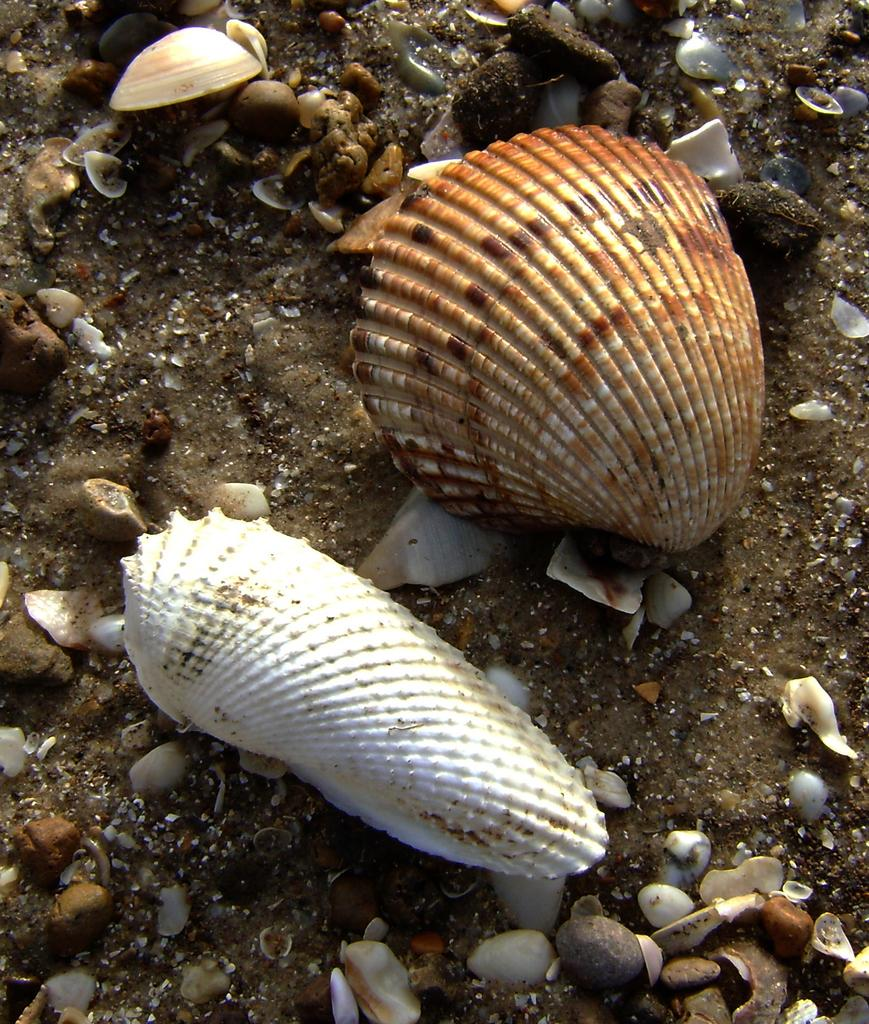What is the main subject of the image? The main subject of the image is seashells. Can you describe the seashells in the image? The seashells come in different colors and sizes. What else can be seen in the image besides seashells? There is sand visible in the image. What type of activity are the ants participating in with the seashells in the image? There are no ants present in the image, so it is not possible to determine what activity they might be participating in with the seashells. Can you describe the taste of the seashells in the image? Seashells are not edible, so it is not possible to describe their taste. 